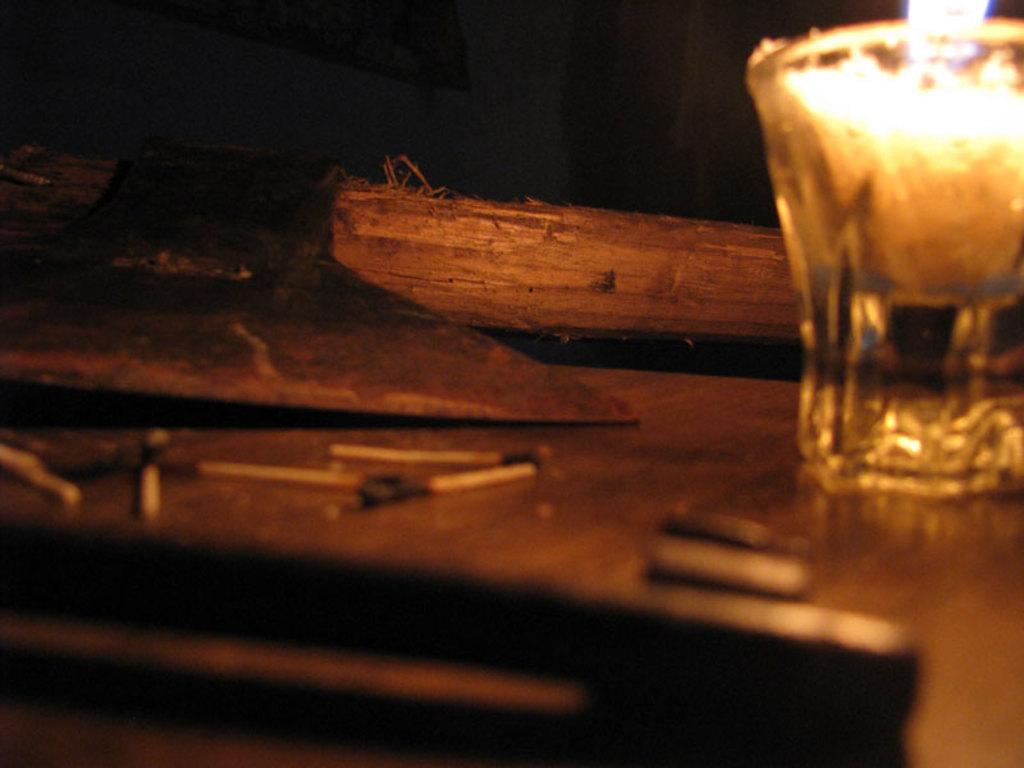What piece of furniture is present in the image? There is a table in the image. What is placed on the table? There is a glass, a candle, a light, wooden sticks, and matchsticks on the table. Can you describe the candle in the image? The candle is on the table. What might be used to light the candle in the image? Matchsticks are present on the table, which could be used to light the candle. How many servants are visible in the image? There are no servants present in the image. What type of sky is visible in the image? There is no sky visible in the image; it is focused on a table and its contents. 